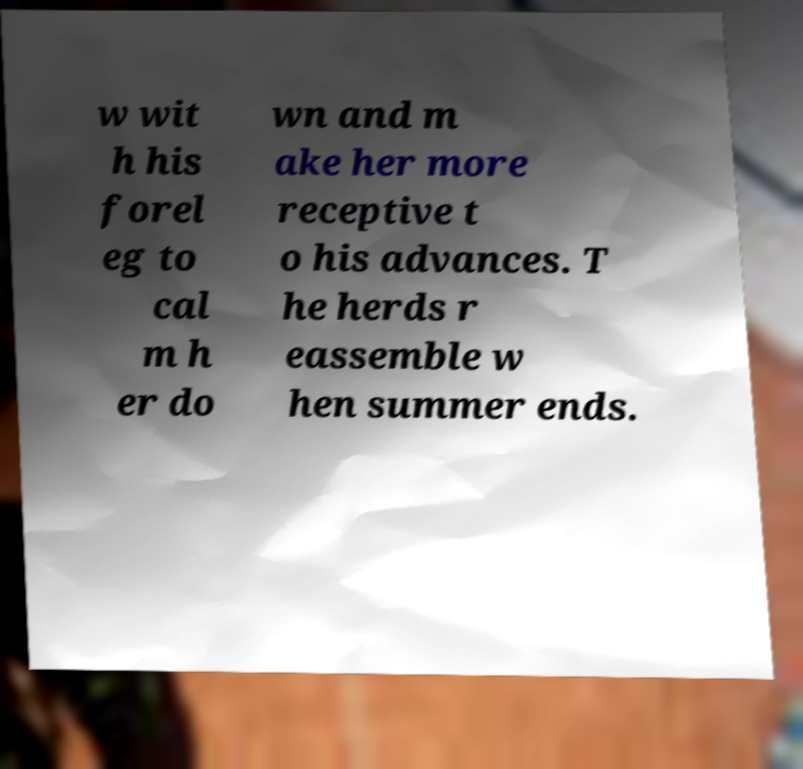Please identify and transcribe the text found in this image. w wit h his forel eg to cal m h er do wn and m ake her more receptive t o his advances. T he herds r eassemble w hen summer ends. 